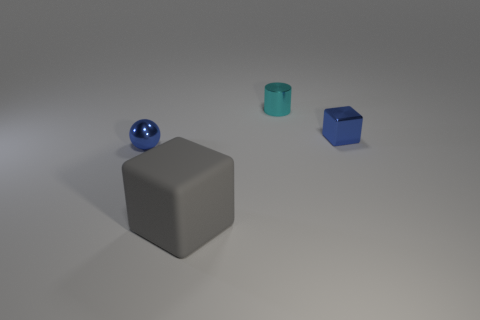Is there anything else that has the same size as the gray object?
Your answer should be very brief. No. Is there anything else that is the same shape as the cyan shiny object?
Your response must be concise. No. There is a tiny blue shiny object to the left of the blue cube; what shape is it?
Provide a succinct answer. Sphere. How many purple cubes have the same size as the metallic cylinder?
Keep it short and to the point. 0. What size is the gray matte cube?
Your answer should be compact. Large. There is a blue ball; what number of metallic things are left of it?
Offer a terse response. 0. There is a tiny cyan thing that is the same material as the sphere; what shape is it?
Provide a succinct answer. Cylinder. Is the number of cyan things in front of the large block less than the number of large matte objects that are to the left of the small metallic cylinder?
Make the answer very short. Yes. Is the number of small metallic balls greater than the number of tiny gray objects?
Offer a very short reply. Yes. What material is the big gray thing?
Offer a very short reply. Rubber. 